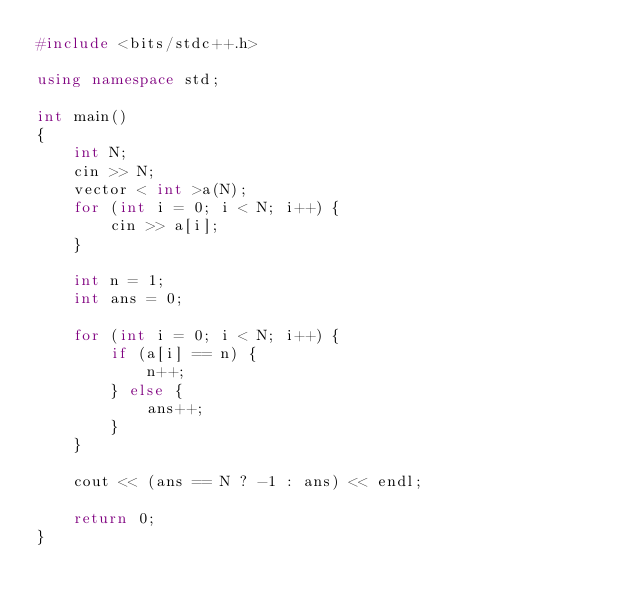<code> <loc_0><loc_0><loc_500><loc_500><_C++_>#include <bits/stdc++.h>

using namespace std;

int main()
{
	int N;
	cin >> N;
	vector < int >a(N);
	for (int i = 0; i < N; i++) {
		cin >> a[i];
	}

	int n = 1;
	int ans = 0;

	for (int i = 0; i < N; i++) {
		if (a[i] == n) {
			n++;
		} else {
			ans++;
		}
	}

	cout << (ans == N ? -1 : ans) << endl;

	return 0;
}
</code> 